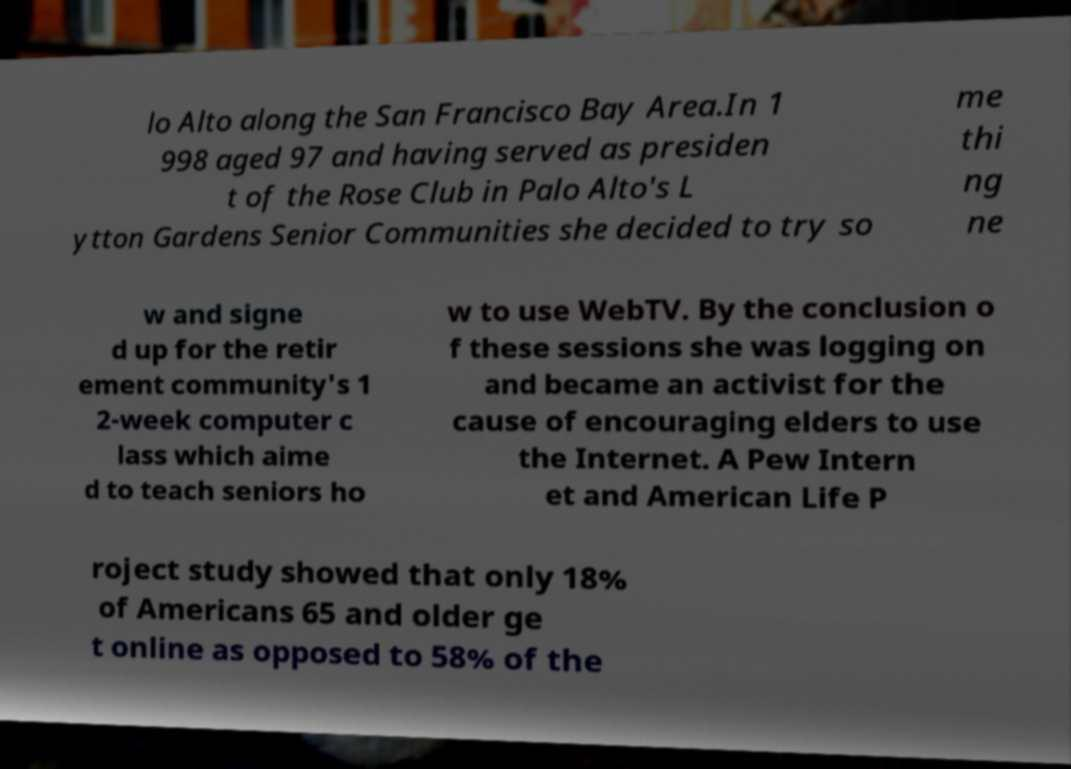Could you assist in decoding the text presented in this image and type it out clearly? lo Alto along the San Francisco Bay Area.In 1 998 aged 97 and having served as presiden t of the Rose Club in Palo Alto's L ytton Gardens Senior Communities she decided to try so me thi ng ne w and signe d up for the retir ement community's 1 2-week computer c lass which aime d to teach seniors ho w to use WebTV. By the conclusion o f these sessions she was logging on and became an activist for the cause of encouraging elders to use the Internet. A Pew Intern et and American Life P roject study showed that only 18% of Americans 65 and older ge t online as opposed to 58% of the 